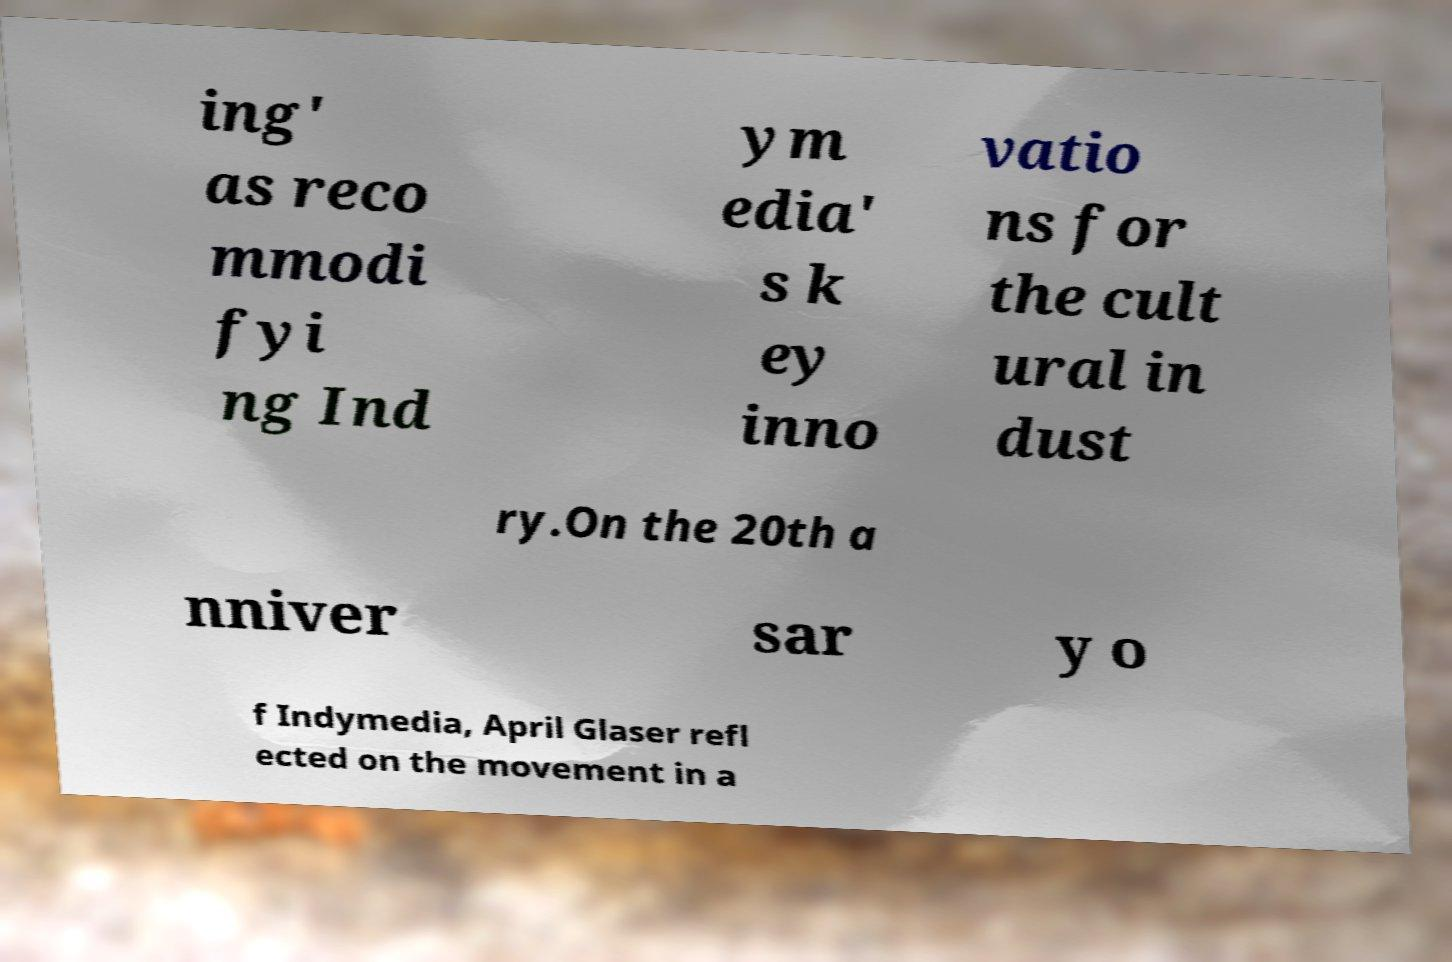There's text embedded in this image that I need extracted. Can you transcribe it verbatim? ing' as reco mmodi fyi ng Ind ym edia' s k ey inno vatio ns for the cult ural in dust ry.On the 20th a nniver sar y o f Indymedia, April Glaser refl ected on the movement in a 